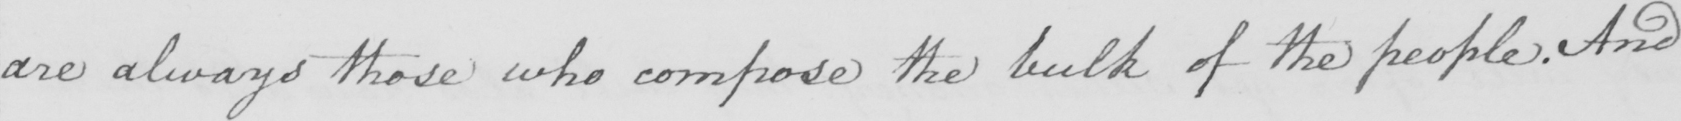Please transcribe the handwritten text in this image. are always those who compose the bulk of the people . And 